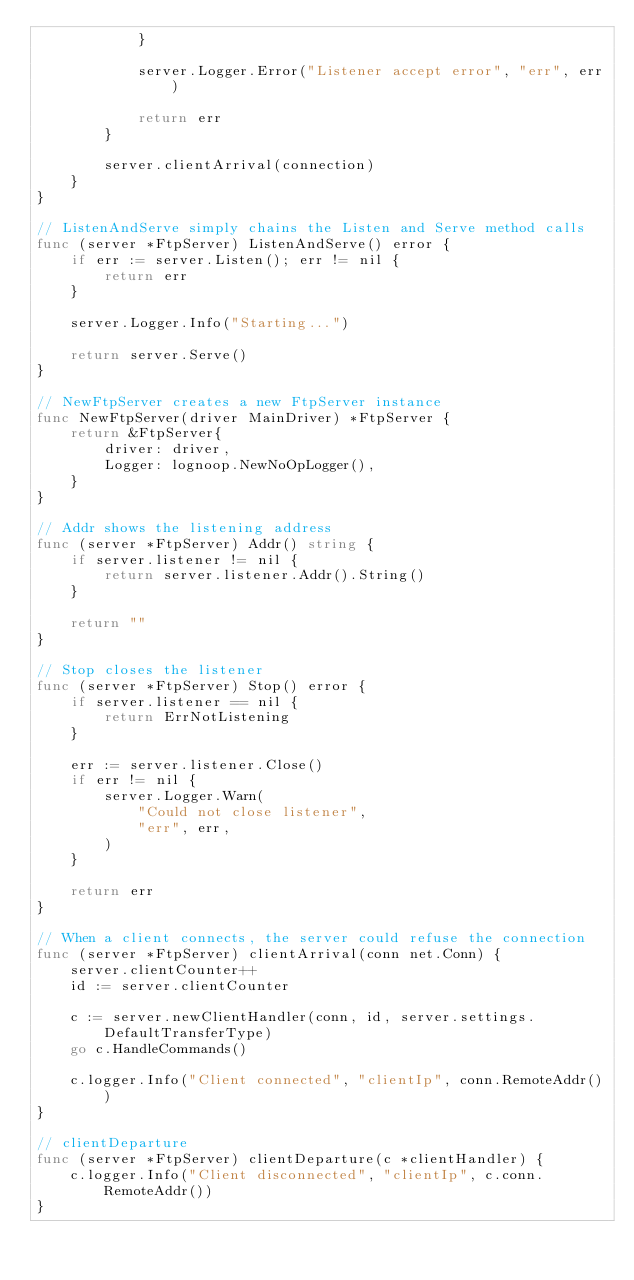Convert code to text. <code><loc_0><loc_0><loc_500><loc_500><_Go_>			}

			server.Logger.Error("Listener accept error", "err", err)

			return err
		}

		server.clientArrival(connection)
	}
}

// ListenAndServe simply chains the Listen and Serve method calls
func (server *FtpServer) ListenAndServe() error {
	if err := server.Listen(); err != nil {
		return err
	}

	server.Logger.Info("Starting...")

	return server.Serve()
}

// NewFtpServer creates a new FtpServer instance
func NewFtpServer(driver MainDriver) *FtpServer {
	return &FtpServer{
		driver: driver,
		Logger: lognoop.NewNoOpLogger(),
	}
}

// Addr shows the listening address
func (server *FtpServer) Addr() string {
	if server.listener != nil {
		return server.listener.Addr().String()
	}

	return ""
}

// Stop closes the listener
func (server *FtpServer) Stop() error {
	if server.listener == nil {
		return ErrNotListening
	}

	err := server.listener.Close()
	if err != nil {
		server.Logger.Warn(
			"Could not close listener",
			"err", err,
		)
	}

	return err
}

// When a client connects, the server could refuse the connection
func (server *FtpServer) clientArrival(conn net.Conn) {
	server.clientCounter++
	id := server.clientCounter

	c := server.newClientHandler(conn, id, server.settings.DefaultTransferType)
	go c.HandleCommands()

	c.logger.Info("Client connected", "clientIp", conn.RemoteAddr())
}

// clientDeparture
func (server *FtpServer) clientDeparture(c *clientHandler) {
	c.logger.Info("Client disconnected", "clientIp", c.conn.RemoteAddr())
}
</code> 